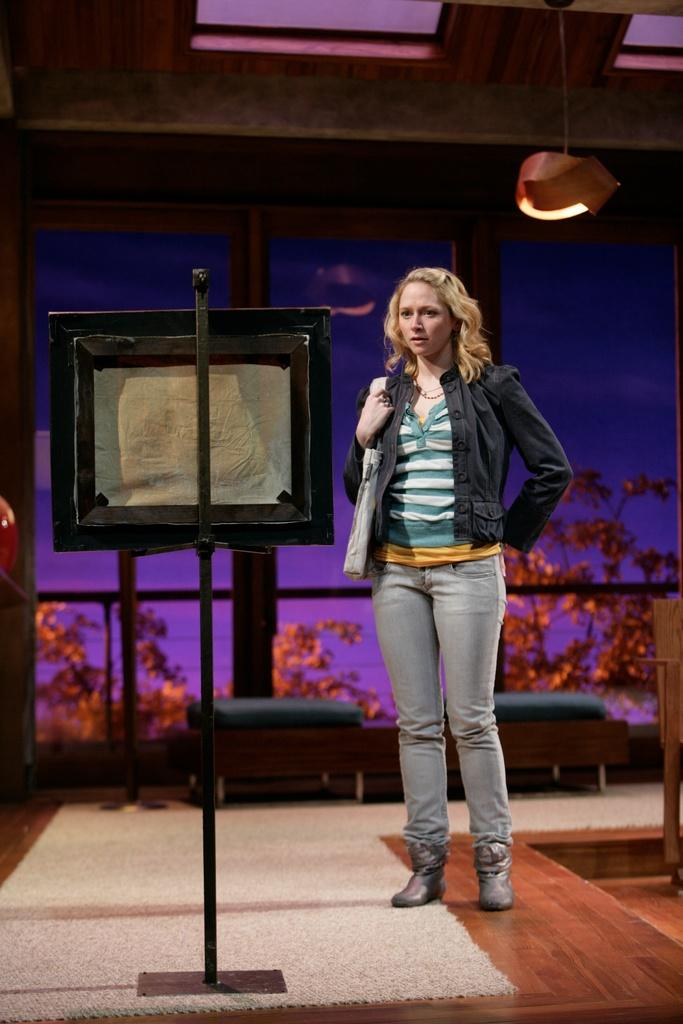What is the main subject of the image? There is a lady standing in the image. What is in front of the lady? There is a stand with a board in front of the lady. What can be seen in the background of the image? There is a window in the background of the image, and trees are visible near the window. What type of lighting is present in the image? There is a light on the ceiling in the image. What year is depicted in the image? The image does not depict a specific year; it is a photograph of a lady standing in front of a stand with a board. What smell can be detected in the image? There is no information about smells in the image; it is a visual representation of a lady standing in front of a stand with a board. 